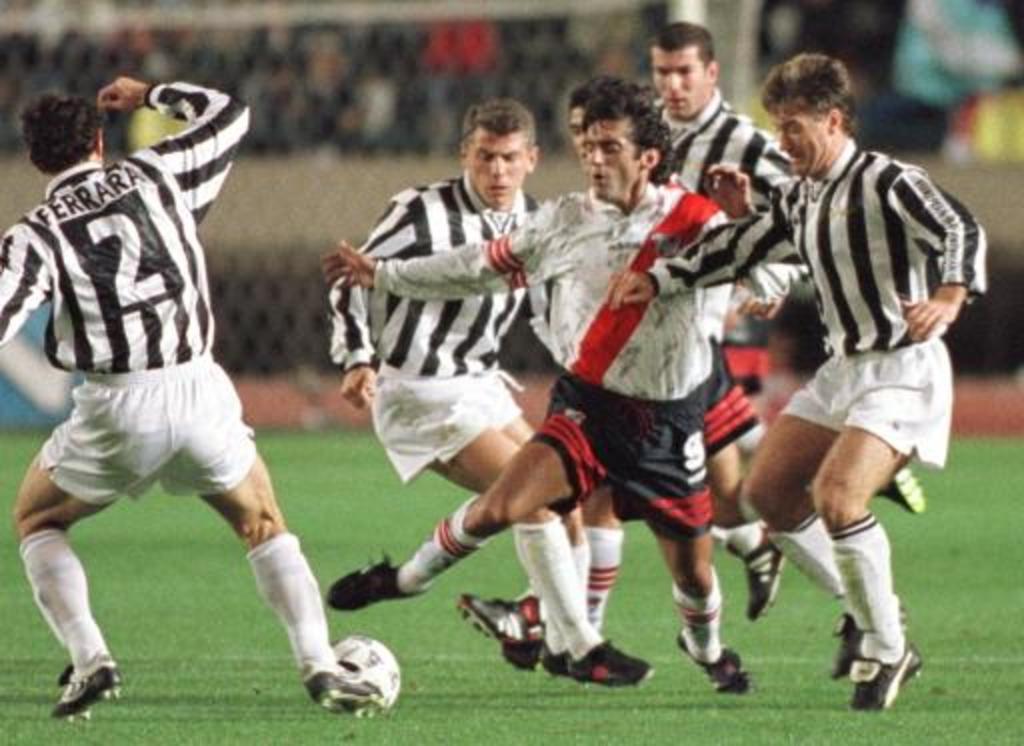What name is on the back of the jersey that has the number 2?
Keep it short and to the point. Ferrara. What number is on the shorts of the player with the red stripe?
Keep it short and to the point. 9. 